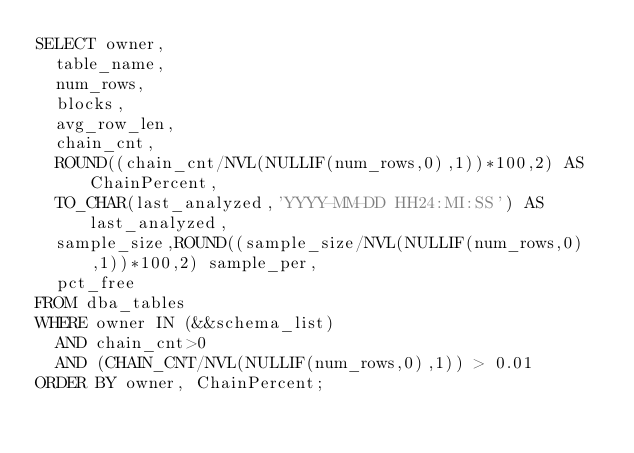Convert code to text. <code><loc_0><loc_0><loc_500><loc_500><_SQL_>SELECT owner,
  table_name,
  num_rows,
  blocks,
  avg_row_len,
  chain_cnt,
  ROUND((chain_cnt/NVL(NULLIF(num_rows,0),1))*100,2) AS ChainPercent,
  TO_CHAR(last_analyzed,'YYYY-MM-DD HH24:MI:SS') AS last_analyzed,
  sample_size,ROUND((sample_size/NVL(NULLIF(num_rows,0),1))*100,2) sample_per,
  pct_free
FROM dba_tables
WHERE owner IN (&&schema_list)
  AND chain_cnt>0 
  AND (CHAIN_CNT/NVL(NULLIF(num_rows,0),1)) > 0.01
ORDER BY owner, ChainPercent;
</code> 